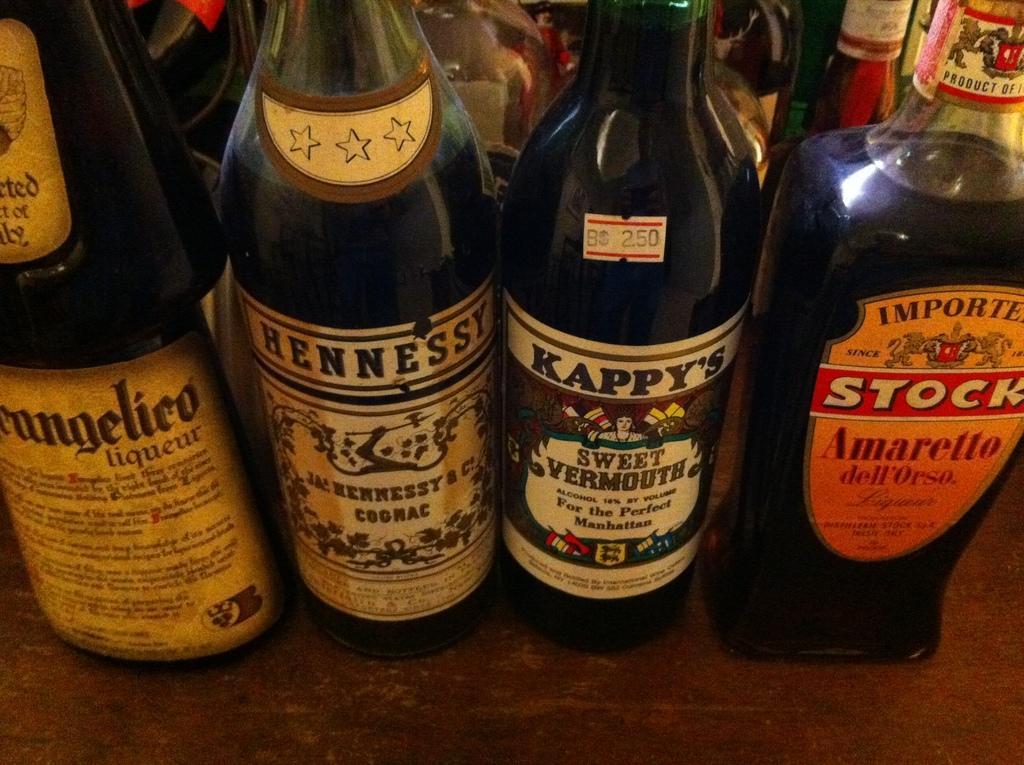In one or two sentences, can you explain what this image depicts? As we can see in the image there are few bottles on tables. 